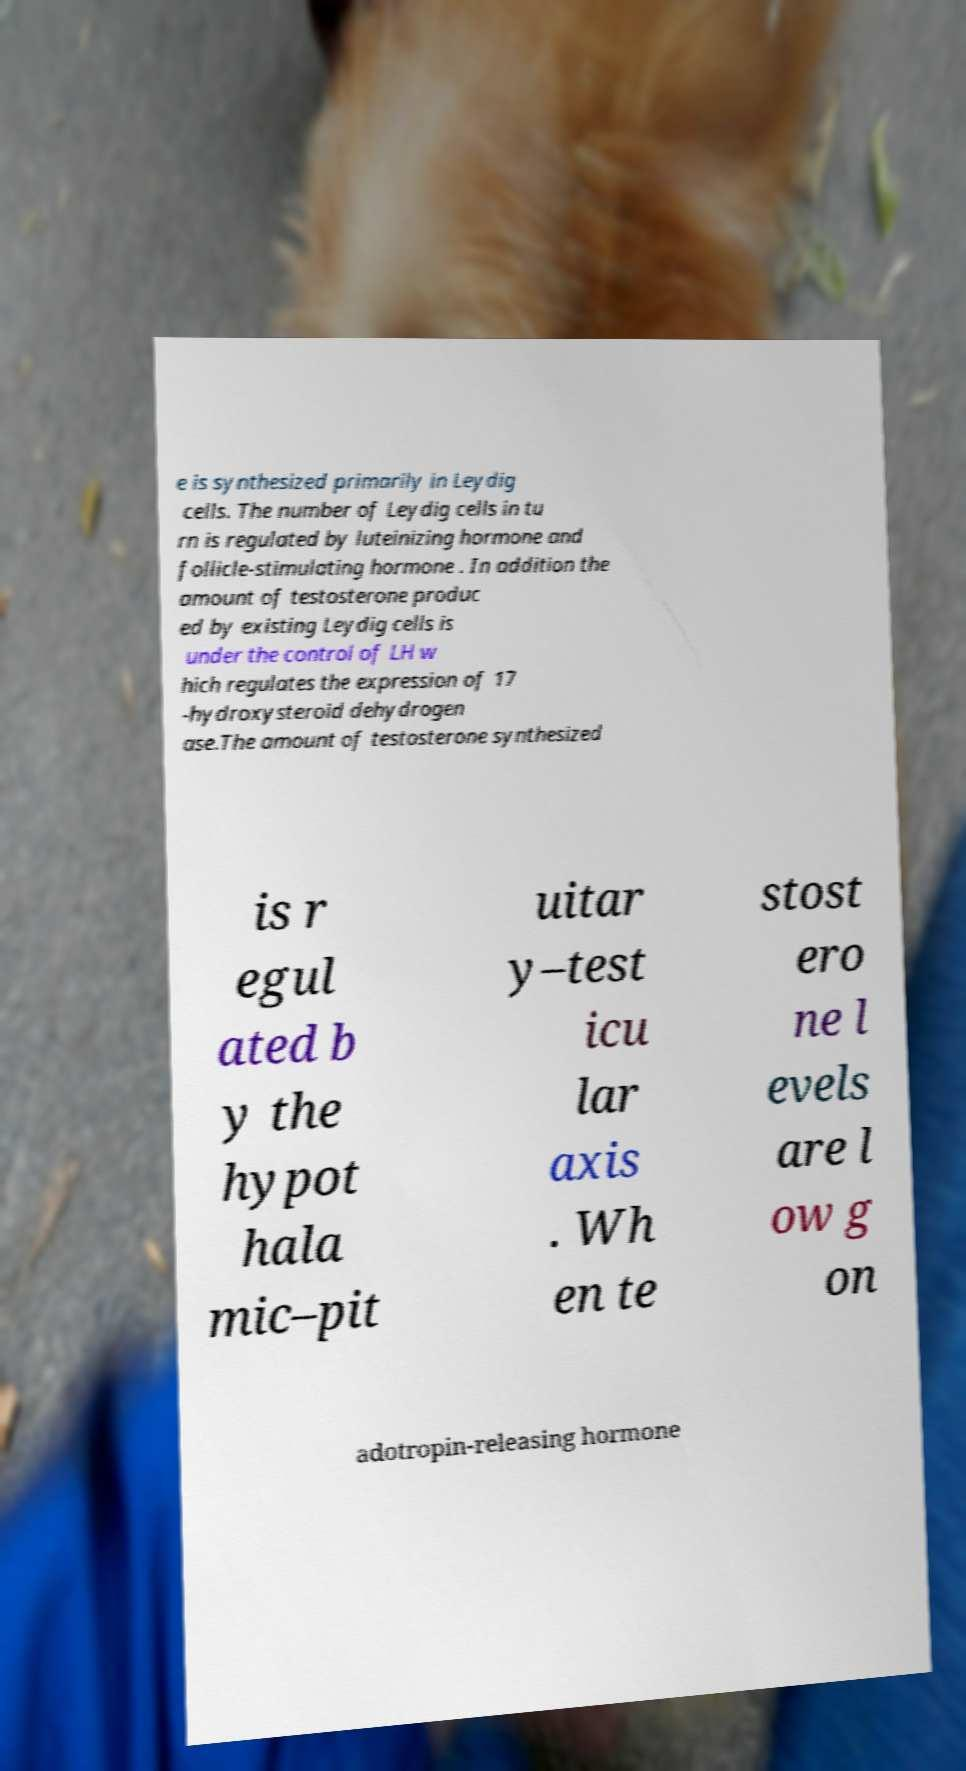I need the written content from this picture converted into text. Can you do that? e is synthesized primarily in Leydig cells. The number of Leydig cells in tu rn is regulated by luteinizing hormone and follicle-stimulating hormone . In addition the amount of testosterone produc ed by existing Leydig cells is under the control of LH w hich regulates the expression of 17 -hydroxysteroid dehydrogen ase.The amount of testosterone synthesized is r egul ated b y the hypot hala mic–pit uitar y–test icu lar axis . Wh en te stost ero ne l evels are l ow g on adotropin-releasing hormone 